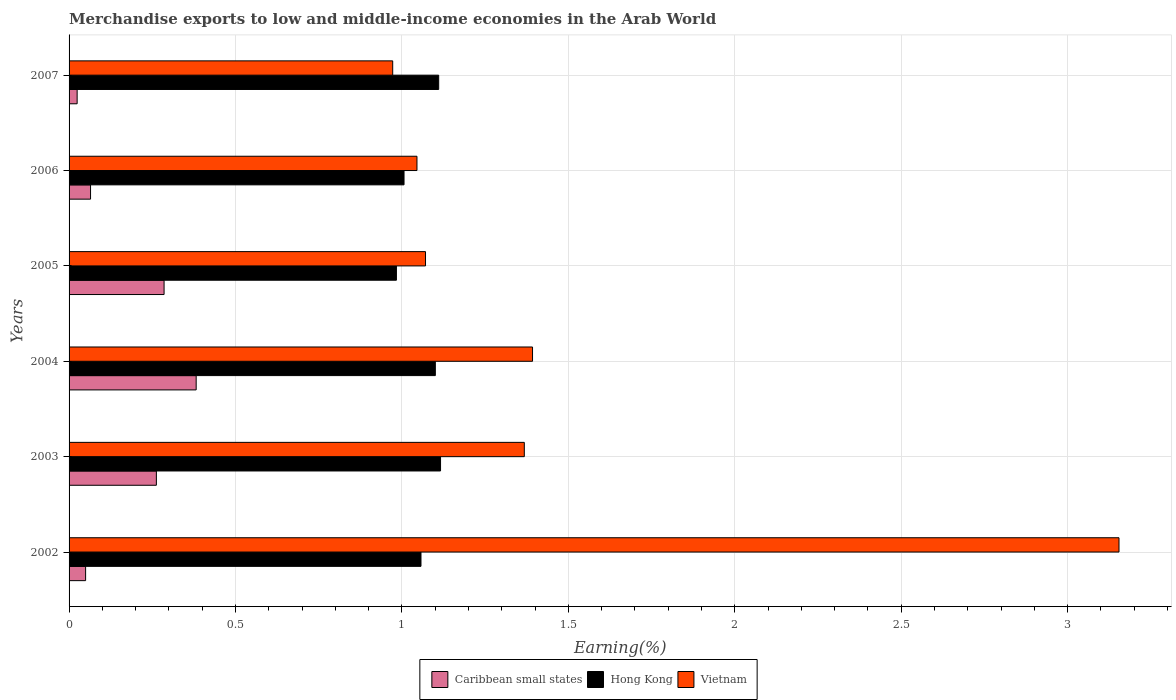How many groups of bars are there?
Your answer should be very brief. 6. Are the number of bars on each tick of the Y-axis equal?
Keep it short and to the point. Yes. How many bars are there on the 4th tick from the top?
Give a very brief answer. 3. How many bars are there on the 4th tick from the bottom?
Offer a terse response. 3. What is the label of the 4th group of bars from the top?
Make the answer very short. 2004. What is the percentage of amount earned from merchandise exports in Caribbean small states in 2004?
Offer a very short reply. 0.38. Across all years, what is the maximum percentage of amount earned from merchandise exports in Vietnam?
Offer a terse response. 3.15. Across all years, what is the minimum percentage of amount earned from merchandise exports in Vietnam?
Offer a very short reply. 0.97. In which year was the percentage of amount earned from merchandise exports in Hong Kong minimum?
Make the answer very short. 2005. What is the total percentage of amount earned from merchandise exports in Hong Kong in the graph?
Ensure brevity in your answer.  6.37. What is the difference between the percentage of amount earned from merchandise exports in Caribbean small states in 2002 and that in 2006?
Ensure brevity in your answer.  -0.01. What is the difference between the percentage of amount earned from merchandise exports in Hong Kong in 2004 and the percentage of amount earned from merchandise exports in Vietnam in 2007?
Offer a very short reply. 0.13. What is the average percentage of amount earned from merchandise exports in Hong Kong per year?
Give a very brief answer. 1.06. In the year 2005, what is the difference between the percentage of amount earned from merchandise exports in Vietnam and percentage of amount earned from merchandise exports in Caribbean small states?
Your answer should be very brief. 0.79. What is the ratio of the percentage of amount earned from merchandise exports in Hong Kong in 2002 to that in 2003?
Ensure brevity in your answer.  0.95. What is the difference between the highest and the second highest percentage of amount earned from merchandise exports in Hong Kong?
Keep it short and to the point. 0.01. What is the difference between the highest and the lowest percentage of amount earned from merchandise exports in Vietnam?
Give a very brief answer. 2.18. Is the sum of the percentage of amount earned from merchandise exports in Hong Kong in 2002 and 2005 greater than the maximum percentage of amount earned from merchandise exports in Vietnam across all years?
Your answer should be very brief. No. What does the 1st bar from the top in 2003 represents?
Your response must be concise. Vietnam. What does the 2nd bar from the bottom in 2005 represents?
Your answer should be very brief. Hong Kong. Is it the case that in every year, the sum of the percentage of amount earned from merchandise exports in Caribbean small states and percentage of amount earned from merchandise exports in Vietnam is greater than the percentage of amount earned from merchandise exports in Hong Kong?
Offer a very short reply. No. Are the values on the major ticks of X-axis written in scientific E-notation?
Offer a terse response. No. Does the graph contain grids?
Provide a succinct answer. Yes. Where does the legend appear in the graph?
Make the answer very short. Bottom center. How are the legend labels stacked?
Provide a succinct answer. Horizontal. What is the title of the graph?
Your answer should be very brief. Merchandise exports to low and middle-income economies in the Arab World. Does "Bosnia and Herzegovina" appear as one of the legend labels in the graph?
Provide a succinct answer. No. What is the label or title of the X-axis?
Offer a terse response. Earning(%). What is the label or title of the Y-axis?
Offer a terse response. Years. What is the Earning(%) in Caribbean small states in 2002?
Your answer should be very brief. 0.05. What is the Earning(%) of Hong Kong in 2002?
Your answer should be very brief. 1.06. What is the Earning(%) of Vietnam in 2002?
Offer a terse response. 3.15. What is the Earning(%) of Caribbean small states in 2003?
Your answer should be compact. 0.26. What is the Earning(%) of Hong Kong in 2003?
Keep it short and to the point. 1.12. What is the Earning(%) of Vietnam in 2003?
Your answer should be compact. 1.37. What is the Earning(%) in Caribbean small states in 2004?
Your answer should be compact. 0.38. What is the Earning(%) of Hong Kong in 2004?
Ensure brevity in your answer.  1.1. What is the Earning(%) in Vietnam in 2004?
Keep it short and to the point. 1.39. What is the Earning(%) of Caribbean small states in 2005?
Your answer should be very brief. 0.29. What is the Earning(%) of Hong Kong in 2005?
Give a very brief answer. 0.98. What is the Earning(%) in Vietnam in 2005?
Your answer should be very brief. 1.07. What is the Earning(%) in Caribbean small states in 2006?
Give a very brief answer. 0.06. What is the Earning(%) of Hong Kong in 2006?
Offer a very short reply. 1.01. What is the Earning(%) of Vietnam in 2006?
Make the answer very short. 1.05. What is the Earning(%) in Caribbean small states in 2007?
Make the answer very short. 0.02. What is the Earning(%) of Hong Kong in 2007?
Make the answer very short. 1.11. What is the Earning(%) of Vietnam in 2007?
Your response must be concise. 0.97. Across all years, what is the maximum Earning(%) in Caribbean small states?
Give a very brief answer. 0.38. Across all years, what is the maximum Earning(%) in Hong Kong?
Ensure brevity in your answer.  1.12. Across all years, what is the maximum Earning(%) of Vietnam?
Your answer should be very brief. 3.15. Across all years, what is the minimum Earning(%) of Caribbean small states?
Ensure brevity in your answer.  0.02. Across all years, what is the minimum Earning(%) of Hong Kong?
Offer a terse response. 0.98. Across all years, what is the minimum Earning(%) of Vietnam?
Your response must be concise. 0.97. What is the total Earning(%) in Caribbean small states in the graph?
Your answer should be very brief. 1.07. What is the total Earning(%) of Hong Kong in the graph?
Your answer should be compact. 6.37. What is the total Earning(%) of Vietnam in the graph?
Ensure brevity in your answer.  9. What is the difference between the Earning(%) of Caribbean small states in 2002 and that in 2003?
Provide a succinct answer. -0.21. What is the difference between the Earning(%) in Hong Kong in 2002 and that in 2003?
Make the answer very short. -0.06. What is the difference between the Earning(%) of Vietnam in 2002 and that in 2003?
Your answer should be compact. 1.79. What is the difference between the Earning(%) in Caribbean small states in 2002 and that in 2004?
Provide a short and direct response. -0.33. What is the difference between the Earning(%) in Hong Kong in 2002 and that in 2004?
Keep it short and to the point. -0.04. What is the difference between the Earning(%) of Vietnam in 2002 and that in 2004?
Your response must be concise. 1.76. What is the difference between the Earning(%) of Caribbean small states in 2002 and that in 2005?
Your answer should be very brief. -0.24. What is the difference between the Earning(%) of Hong Kong in 2002 and that in 2005?
Ensure brevity in your answer.  0.07. What is the difference between the Earning(%) in Vietnam in 2002 and that in 2005?
Give a very brief answer. 2.08. What is the difference between the Earning(%) in Caribbean small states in 2002 and that in 2006?
Make the answer very short. -0.01. What is the difference between the Earning(%) of Hong Kong in 2002 and that in 2006?
Ensure brevity in your answer.  0.05. What is the difference between the Earning(%) in Vietnam in 2002 and that in 2006?
Your response must be concise. 2.11. What is the difference between the Earning(%) in Caribbean small states in 2002 and that in 2007?
Provide a succinct answer. 0.03. What is the difference between the Earning(%) of Hong Kong in 2002 and that in 2007?
Offer a terse response. -0.05. What is the difference between the Earning(%) in Vietnam in 2002 and that in 2007?
Offer a very short reply. 2.18. What is the difference between the Earning(%) in Caribbean small states in 2003 and that in 2004?
Ensure brevity in your answer.  -0.12. What is the difference between the Earning(%) in Hong Kong in 2003 and that in 2004?
Keep it short and to the point. 0.02. What is the difference between the Earning(%) of Vietnam in 2003 and that in 2004?
Provide a succinct answer. -0.02. What is the difference between the Earning(%) of Caribbean small states in 2003 and that in 2005?
Give a very brief answer. -0.02. What is the difference between the Earning(%) in Hong Kong in 2003 and that in 2005?
Ensure brevity in your answer.  0.13. What is the difference between the Earning(%) of Vietnam in 2003 and that in 2005?
Your response must be concise. 0.3. What is the difference between the Earning(%) of Caribbean small states in 2003 and that in 2006?
Offer a very short reply. 0.2. What is the difference between the Earning(%) in Hong Kong in 2003 and that in 2006?
Your answer should be very brief. 0.11. What is the difference between the Earning(%) in Vietnam in 2003 and that in 2006?
Your response must be concise. 0.32. What is the difference between the Earning(%) of Caribbean small states in 2003 and that in 2007?
Offer a very short reply. 0.24. What is the difference between the Earning(%) in Hong Kong in 2003 and that in 2007?
Your answer should be compact. 0.01. What is the difference between the Earning(%) of Vietnam in 2003 and that in 2007?
Provide a short and direct response. 0.4. What is the difference between the Earning(%) in Caribbean small states in 2004 and that in 2005?
Provide a short and direct response. 0.1. What is the difference between the Earning(%) in Hong Kong in 2004 and that in 2005?
Your answer should be very brief. 0.12. What is the difference between the Earning(%) of Vietnam in 2004 and that in 2005?
Provide a short and direct response. 0.32. What is the difference between the Earning(%) in Caribbean small states in 2004 and that in 2006?
Keep it short and to the point. 0.32. What is the difference between the Earning(%) of Hong Kong in 2004 and that in 2006?
Your response must be concise. 0.09. What is the difference between the Earning(%) in Vietnam in 2004 and that in 2006?
Your response must be concise. 0.35. What is the difference between the Earning(%) of Caribbean small states in 2004 and that in 2007?
Offer a terse response. 0.36. What is the difference between the Earning(%) in Hong Kong in 2004 and that in 2007?
Keep it short and to the point. -0.01. What is the difference between the Earning(%) of Vietnam in 2004 and that in 2007?
Make the answer very short. 0.42. What is the difference between the Earning(%) of Caribbean small states in 2005 and that in 2006?
Keep it short and to the point. 0.22. What is the difference between the Earning(%) of Hong Kong in 2005 and that in 2006?
Keep it short and to the point. -0.02. What is the difference between the Earning(%) in Vietnam in 2005 and that in 2006?
Provide a short and direct response. 0.03. What is the difference between the Earning(%) in Caribbean small states in 2005 and that in 2007?
Keep it short and to the point. 0.26. What is the difference between the Earning(%) in Hong Kong in 2005 and that in 2007?
Your response must be concise. -0.13. What is the difference between the Earning(%) of Vietnam in 2005 and that in 2007?
Make the answer very short. 0.1. What is the difference between the Earning(%) of Caribbean small states in 2006 and that in 2007?
Provide a short and direct response. 0.04. What is the difference between the Earning(%) in Hong Kong in 2006 and that in 2007?
Your answer should be compact. -0.1. What is the difference between the Earning(%) in Vietnam in 2006 and that in 2007?
Ensure brevity in your answer.  0.07. What is the difference between the Earning(%) of Caribbean small states in 2002 and the Earning(%) of Hong Kong in 2003?
Provide a succinct answer. -1.07. What is the difference between the Earning(%) in Caribbean small states in 2002 and the Earning(%) in Vietnam in 2003?
Give a very brief answer. -1.32. What is the difference between the Earning(%) of Hong Kong in 2002 and the Earning(%) of Vietnam in 2003?
Your answer should be compact. -0.31. What is the difference between the Earning(%) in Caribbean small states in 2002 and the Earning(%) in Hong Kong in 2004?
Provide a succinct answer. -1.05. What is the difference between the Earning(%) of Caribbean small states in 2002 and the Earning(%) of Vietnam in 2004?
Your answer should be compact. -1.34. What is the difference between the Earning(%) of Hong Kong in 2002 and the Earning(%) of Vietnam in 2004?
Ensure brevity in your answer.  -0.34. What is the difference between the Earning(%) in Caribbean small states in 2002 and the Earning(%) in Hong Kong in 2005?
Provide a succinct answer. -0.93. What is the difference between the Earning(%) in Caribbean small states in 2002 and the Earning(%) in Vietnam in 2005?
Make the answer very short. -1.02. What is the difference between the Earning(%) of Hong Kong in 2002 and the Earning(%) of Vietnam in 2005?
Offer a terse response. -0.01. What is the difference between the Earning(%) of Caribbean small states in 2002 and the Earning(%) of Hong Kong in 2006?
Provide a succinct answer. -0.96. What is the difference between the Earning(%) in Caribbean small states in 2002 and the Earning(%) in Vietnam in 2006?
Offer a terse response. -1. What is the difference between the Earning(%) of Hong Kong in 2002 and the Earning(%) of Vietnam in 2006?
Offer a very short reply. 0.01. What is the difference between the Earning(%) in Caribbean small states in 2002 and the Earning(%) in Hong Kong in 2007?
Ensure brevity in your answer.  -1.06. What is the difference between the Earning(%) of Caribbean small states in 2002 and the Earning(%) of Vietnam in 2007?
Your answer should be compact. -0.92. What is the difference between the Earning(%) of Hong Kong in 2002 and the Earning(%) of Vietnam in 2007?
Your answer should be compact. 0.09. What is the difference between the Earning(%) in Caribbean small states in 2003 and the Earning(%) in Hong Kong in 2004?
Provide a short and direct response. -0.84. What is the difference between the Earning(%) of Caribbean small states in 2003 and the Earning(%) of Vietnam in 2004?
Provide a succinct answer. -1.13. What is the difference between the Earning(%) in Hong Kong in 2003 and the Earning(%) in Vietnam in 2004?
Keep it short and to the point. -0.28. What is the difference between the Earning(%) of Caribbean small states in 2003 and the Earning(%) of Hong Kong in 2005?
Provide a succinct answer. -0.72. What is the difference between the Earning(%) in Caribbean small states in 2003 and the Earning(%) in Vietnam in 2005?
Ensure brevity in your answer.  -0.81. What is the difference between the Earning(%) of Hong Kong in 2003 and the Earning(%) of Vietnam in 2005?
Ensure brevity in your answer.  0.05. What is the difference between the Earning(%) of Caribbean small states in 2003 and the Earning(%) of Hong Kong in 2006?
Give a very brief answer. -0.74. What is the difference between the Earning(%) of Caribbean small states in 2003 and the Earning(%) of Vietnam in 2006?
Make the answer very short. -0.78. What is the difference between the Earning(%) in Hong Kong in 2003 and the Earning(%) in Vietnam in 2006?
Make the answer very short. 0.07. What is the difference between the Earning(%) in Caribbean small states in 2003 and the Earning(%) in Hong Kong in 2007?
Your response must be concise. -0.85. What is the difference between the Earning(%) of Caribbean small states in 2003 and the Earning(%) of Vietnam in 2007?
Your response must be concise. -0.71. What is the difference between the Earning(%) in Hong Kong in 2003 and the Earning(%) in Vietnam in 2007?
Offer a terse response. 0.14. What is the difference between the Earning(%) of Caribbean small states in 2004 and the Earning(%) of Hong Kong in 2005?
Ensure brevity in your answer.  -0.6. What is the difference between the Earning(%) of Caribbean small states in 2004 and the Earning(%) of Vietnam in 2005?
Your answer should be very brief. -0.69. What is the difference between the Earning(%) in Hong Kong in 2004 and the Earning(%) in Vietnam in 2005?
Make the answer very short. 0.03. What is the difference between the Earning(%) of Caribbean small states in 2004 and the Earning(%) of Hong Kong in 2006?
Your response must be concise. -0.62. What is the difference between the Earning(%) of Caribbean small states in 2004 and the Earning(%) of Vietnam in 2006?
Provide a short and direct response. -0.66. What is the difference between the Earning(%) in Hong Kong in 2004 and the Earning(%) in Vietnam in 2006?
Give a very brief answer. 0.06. What is the difference between the Earning(%) of Caribbean small states in 2004 and the Earning(%) of Hong Kong in 2007?
Provide a short and direct response. -0.73. What is the difference between the Earning(%) in Caribbean small states in 2004 and the Earning(%) in Vietnam in 2007?
Provide a succinct answer. -0.59. What is the difference between the Earning(%) in Hong Kong in 2004 and the Earning(%) in Vietnam in 2007?
Ensure brevity in your answer.  0.13. What is the difference between the Earning(%) of Caribbean small states in 2005 and the Earning(%) of Hong Kong in 2006?
Provide a succinct answer. -0.72. What is the difference between the Earning(%) of Caribbean small states in 2005 and the Earning(%) of Vietnam in 2006?
Ensure brevity in your answer.  -0.76. What is the difference between the Earning(%) of Hong Kong in 2005 and the Earning(%) of Vietnam in 2006?
Provide a succinct answer. -0.06. What is the difference between the Earning(%) of Caribbean small states in 2005 and the Earning(%) of Hong Kong in 2007?
Ensure brevity in your answer.  -0.82. What is the difference between the Earning(%) in Caribbean small states in 2005 and the Earning(%) in Vietnam in 2007?
Your response must be concise. -0.69. What is the difference between the Earning(%) in Hong Kong in 2005 and the Earning(%) in Vietnam in 2007?
Offer a very short reply. 0.01. What is the difference between the Earning(%) in Caribbean small states in 2006 and the Earning(%) in Hong Kong in 2007?
Make the answer very short. -1.05. What is the difference between the Earning(%) in Caribbean small states in 2006 and the Earning(%) in Vietnam in 2007?
Provide a succinct answer. -0.91. What is the difference between the Earning(%) of Hong Kong in 2006 and the Earning(%) of Vietnam in 2007?
Make the answer very short. 0.03. What is the average Earning(%) of Caribbean small states per year?
Your answer should be very brief. 0.18. What is the average Earning(%) in Hong Kong per year?
Ensure brevity in your answer.  1.06. What is the average Earning(%) of Vietnam per year?
Keep it short and to the point. 1.5. In the year 2002, what is the difference between the Earning(%) of Caribbean small states and Earning(%) of Hong Kong?
Ensure brevity in your answer.  -1.01. In the year 2002, what is the difference between the Earning(%) of Caribbean small states and Earning(%) of Vietnam?
Give a very brief answer. -3.1. In the year 2002, what is the difference between the Earning(%) in Hong Kong and Earning(%) in Vietnam?
Your answer should be compact. -2.1. In the year 2003, what is the difference between the Earning(%) of Caribbean small states and Earning(%) of Hong Kong?
Ensure brevity in your answer.  -0.85. In the year 2003, what is the difference between the Earning(%) of Caribbean small states and Earning(%) of Vietnam?
Keep it short and to the point. -1.11. In the year 2003, what is the difference between the Earning(%) in Hong Kong and Earning(%) in Vietnam?
Your answer should be very brief. -0.25. In the year 2004, what is the difference between the Earning(%) in Caribbean small states and Earning(%) in Hong Kong?
Provide a succinct answer. -0.72. In the year 2004, what is the difference between the Earning(%) in Caribbean small states and Earning(%) in Vietnam?
Give a very brief answer. -1.01. In the year 2004, what is the difference between the Earning(%) in Hong Kong and Earning(%) in Vietnam?
Your answer should be very brief. -0.29. In the year 2005, what is the difference between the Earning(%) of Caribbean small states and Earning(%) of Hong Kong?
Offer a very short reply. -0.7. In the year 2005, what is the difference between the Earning(%) in Caribbean small states and Earning(%) in Vietnam?
Ensure brevity in your answer.  -0.79. In the year 2005, what is the difference between the Earning(%) in Hong Kong and Earning(%) in Vietnam?
Provide a short and direct response. -0.09. In the year 2006, what is the difference between the Earning(%) in Caribbean small states and Earning(%) in Hong Kong?
Offer a terse response. -0.94. In the year 2006, what is the difference between the Earning(%) of Caribbean small states and Earning(%) of Vietnam?
Give a very brief answer. -0.98. In the year 2006, what is the difference between the Earning(%) of Hong Kong and Earning(%) of Vietnam?
Ensure brevity in your answer.  -0.04. In the year 2007, what is the difference between the Earning(%) of Caribbean small states and Earning(%) of Hong Kong?
Your answer should be compact. -1.09. In the year 2007, what is the difference between the Earning(%) in Caribbean small states and Earning(%) in Vietnam?
Provide a short and direct response. -0.95. In the year 2007, what is the difference between the Earning(%) of Hong Kong and Earning(%) of Vietnam?
Your response must be concise. 0.14. What is the ratio of the Earning(%) in Caribbean small states in 2002 to that in 2003?
Your answer should be very brief. 0.19. What is the ratio of the Earning(%) of Hong Kong in 2002 to that in 2003?
Your answer should be very brief. 0.95. What is the ratio of the Earning(%) of Vietnam in 2002 to that in 2003?
Offer a terse response. 2.31. What is the ratio of the Earning(%) in Caribbean small states in 2002 to that in 2004?
Give a very brief answer. 0.13. What is the ratio of the Earning(%) in Hong Kong in 2002 to that in 2004?
Provide a succinct answer. 0.96. What is the ratio of the Earning(%) of Vietnam in 2002 to that in 2004?
Offer a very short reply. 2.27. What is the ratio of the Earning(%) in Caribbean small states in 2002 to that in 2005?
Provide a succinct answer. 0.17. What is the ratio of the Earning(%) of Hong Kong in 2002 to that in 2005?
Offer a very short reply. 1.07. What is the ratio of the Earning(%) in Vietnam in 2002 to that in 2005?
Offer a very short reply. 2.95. What is the ratio of the Earning(%) in Caribbean small states in 2002 to that in 2006?
Offer a terse response. 0.77. What is the ratio of the Earning(%) of Hong Kong in 2002 to that in 2006?
Make the answer very short. 1.05. What is the ratio of the Earning(%) of Vietnam in 2002 to that in 2006?
Keep it short and to the point. 3.02. What is the ratio of the Earning(%) in Caribbean small states in 2002 to that in 2007?
Your answer should be compact. 2.05. What is the ratio of the Earning(%) of Hong Kong in 2002 to that in 2007?
Your answer should be very brief. 0.95. What is the ratio of the Earning(%) of Vietnam in 2002 to that in 2007?
Make the answer very short. 3.24. What is the ratio of the Earning(%) in Caribbean small states in 2003 to that in 2004?
Ensure brevity in your answer.  0.69. What is the ratio of the Earning(%) of Hong Kong in 2003 to that in 2004?
Your answer should be compact. 1.01. What is the ratio of the Earning(%) of Vietnam in 2003 to that in 2004?
Ensure brevity in your answer.  0.98. What is the ratio of the Earning(%) of Caribbean small states in 2003 to that in 2005?
Make the answer very short. 0.92. What is the ratio of the Earning(%) in Hong Kong in 2003 to that in 2005?
Offer a very short reply. 1.13. What is the ratio of the Earning(%) of Vietnam in 2003 to that in 2005?
Ensure brevity in your answer.  1.28. What is the ratio of the Earning(%) of Caribbean small states in 2003 to that in 2006?
Give a very brief answer. 4.06. What is the ratio of the Earning(%) in Hong Kong in 2003 to that in 2006?
Keep it short and to the point. 1.11. What is the ratio of the Earning(%) of Vietnam in 2003 to that in 2006?
Keep it short and to the point. 1.31. What is the ratio of the Earning(%) of Caribbean small states in 2003 to that in 2007?
Your answer should be compact. 10.82. What is the ratio of the Earning(%) of Hong Kong in 2003 to that in 2007?
Your answer should be very brief. 1.01. What is the ratio of the Earning(%) in Vietnam in 2003 to that in 2007?
Offer a terse response. 1.41. What is the ratio of the Earning(%) in Caribbean small states in 2004 to that in 2005?
Your response must be concise. 1.34. What is the ratio of the Earning(%) in Hong Kong in 2004 to that in 2005?
Offer a very short reply. 1.12. What is the ratio of the Earning(%) in Vietnam in 2004 to that in 2005?
Make the answer very short. 1.3. What is the ratio of the Earning(%) of Caribbean small states in 2004 to that in 2006?
Offer a very short reply. 5.92. What is the ratio of the Earning(%) of Hong Kong in 2004 to that in 2006?
Provide a succinct answer. 1.09. What is the ratio of the Earning(%) of Vietnam in 2004 to that in 2006?
Provide a succinct answer. 1.33. What is the ratio of the Earning(%) of Caribbean small states in 2004 to that in 2007?
Ensure brevity in your answer.  15.75. What is the ratio of the Earning(%) in Hong Kong in 2004 to that in 2007?
Offer a terse response. 0.99. What is the ratio of the Earning(%) in Vietnam in 2004 to that in 2007?
Your answer should be very brief. 1.43. What is the ratio of the Earning(%) of Caribbean small states in 2005 to that in 2006?
Your answer should be very brief. 4.42. What is the ratio of the Earning(%) of Hong Kong in 2005 to that in 2006?
Your answer should be very brief. 0.98. What is the ratio of the Earning(%) in Vietnam in 2005 to that in 2006?
Offer a terse response. 1.02. What is the ratio of the Earning(%) in Caribbean small states in 2005 to that in 2007?
Provide a succinct answer. 11.78. What is the ratio of the Earning(%) in Hong Kong in 2005 to that in 2007?
Your answer should be very brief. 0.89. What is the ratio of the Earning(%) in Vietnam in 2005 to that in 2007?
Offer a very short reply. 1.1. What is the ratio of the Earning(%) in Caribbean small states in 2006 to that in 2007?
Provide a succinct answer. 2.66. What is the ratio of the Earning(%) in Hong Kong in 2006 to that in 2007?
Your answer should be very brief. 0.91. What is the ratio of the Earning(%) of Vietnam in 2006 to that in 2007?
Provide a short and direct response. 1.07. What is the difference between the highest and the second highest Earning(%) of Caribbean small states?
Your response must be concise. 0.1. What is the difference between the highest and the second highest Earning(%) of Hong Kong?
Provide a short and direct response. 0.01. What is the difference between the highest and the second highest Earning(%) of Vietnam?
Your answer should be compact. 1.76. What is the difference between the highest and the lowest Earning(%) in Caribbean small states?
Your answer should be very brief. 0.36. What is the difference between the highest and the lowest Earning(%) in Hong Kong?
Provide a succinct answer. 0.13. What is the difference between the highest and the lowest Earning(%) in Vietnam?
Your response must be concise. 2.18. 